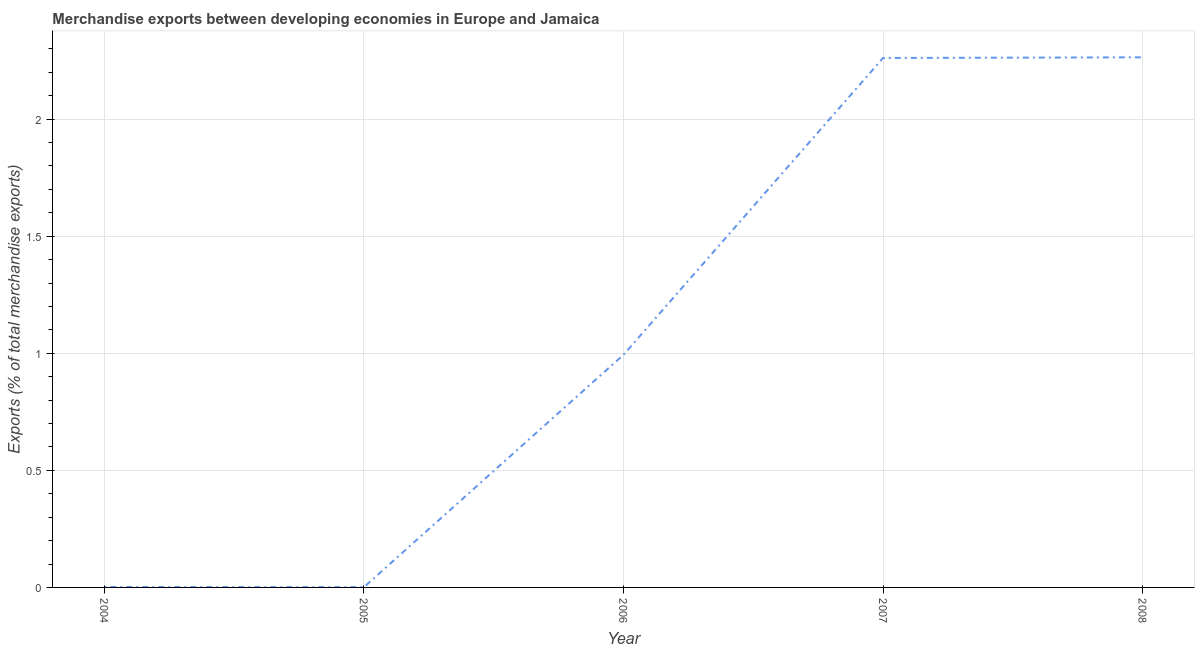What is the merchandise exports in 2004?
Your response must be concise. 0. Across all years, what is the maximum merchandise exports?
Keep it short and to the point. 2.26. Across all years, what is the minimum merchandise exports?
Make the answer very short. 0. What is the sum of the merchandise exports?
Your response must be concise. 5.52. What is the difference between the merchandise exports in 2004 and 2008?
Make the answer very short. -2.26. What is the average merchandise exports per year?
Keep it short and to the point. 1.1. What is the median merchandise exports?
Your response must be concise. 0.99. In how many years, is the merchandise exports greater than 0.7 %?
Make the answer very short. 3. Do a majority of the years between 2005 and 2007 (inclusive) have merchandise exports greater than 1 %?
Provide a short and direct response. No. What is the ratio of the merchandise exports in 2006 to that in 2008?
Ensure brevity in your answer.  0.44. Is the merchandise exports in 2004 less than that in 2007?
Your answer should be very brief. Yes. Is the difference between the merchandise exports in 2006 and 2007 greater than the difference between any two years?
Your response must be concise. No. What is the difference between the highest and the second highest merchandise exports?
Provide a short and direct response. 0. Is the sum of the merchandise exports in 2006 and 2007 greater than the maximum merchandise exports across all years?
Keep it short and to the point. Yes. What is the difference between the highest and the lowest merchandise exports?
Make the answer very short. 2.26. Does the merchandise exports monotonically increase over the years?
Ensure brevity in your answer.  No. How many lines are there?
Make the answer very short. 1. How many years are there in the graph?
Offer a very short reply. 5. Are the values on the major ticks of Y-axis written in scientific E-notation?
Keep it short and to the point. No. What is the title of the graph?
Offer a terse response. Merchandise exports between developing economies in Europe and Jamaica. What is the label or title of the Y-axis?
Give a very brief answer. Exports (% of total merchandise exports). What is the Exports (% of total merchandise exports) of 2004?
Offer a very short reply. 0. What is the Exports (% of total merchandise exports) in 2005?
Provide a succinct answer. 0. What is the Exports (% of total merchandise exports) of 2006?
Offer a terse response. 0.99. What is the Exports (% of total merchandise exports) in 2007?
Your response must be concise. 2.26. What is the Exports (% of total merchandise exports) in 2008?
Your answer should be very brief. 2.26. What is the difference between the Exports (% of total merchandise exports) in 2004 and 2005?
Provide a short and direct response. 0. What is the difference between the Exports (% of total merchandise exports) in 2004 and 2006?
Offer a terse response. -0.99. What is the difference between the Exports (% of total merchandise exports) in 2004 and 2007?
Provide a short and direct response. -2.26. What is the difference between the Exports (% of total merchandise exports) in 2004 and 2008?
Provide a short and direct response. -2.26. What is the difference between the Exports (% of total merchandise exports) in 2005 and 2006?
Give a very brief answer. -0.99. What is the difference between the Exports (% of total merchandise exports) in 2005 and 2007?
Give a very brief answer. -2.26. What is the difference between the Exports (% of total merchandise exports) in 2005 and 2008?
Provide a short and direct response. -2.26. What is the difference between the Exports (% of total merchandise exports) in 2006 and 2007?
Make the answer very short. -1.27. What is the difference between the Exports (% of total merchandise exports) in 2006 and 2008?
Your answer should be compact. -1.27. What is the difference between the Exports (% of total merchandise exports) in 2007 and 2008?
Provide a succinct answer. -0. What is the ratio of the Exports (% of total merchandise exports) in 2004 to that in 2005?
Keep it short and to the point. 1.49. What is the ratio of the Exports (% of total merchandise exports) in 2004 to that in 2006?
Give a very brief answer. 0. What is the ratio of the Exports (% of total merchandise exports) in 2004 to that in 2007?
Make the answer very short. 0. What is the ratio of the Exports (% of total merchandise exports) in 2004 to that in 2008?
Give a very brief answer. 0. What is the ratio of the Exports (% of total merchandise exports) in 2005 to that in 2006?
Provide a short and direct response. 0. What is the ratio of the Exports (% of total merchandise exports) in 2005 to that in 2007?
Your answer should be very brief. 0. What is the ratio of the Exports (% of total merchandise exports) in 2005 to that in 2008?
Provide a short and direct response. 0. What is the ratio of the Exports (% of total merchandise exports) in 2006 to that in 2007?
Offer a terse response. 0.44. What is the ratio of the Exports (% of total merchandise exports) in 2006 to that in 2008?
Make the answer very short. 0.44. 